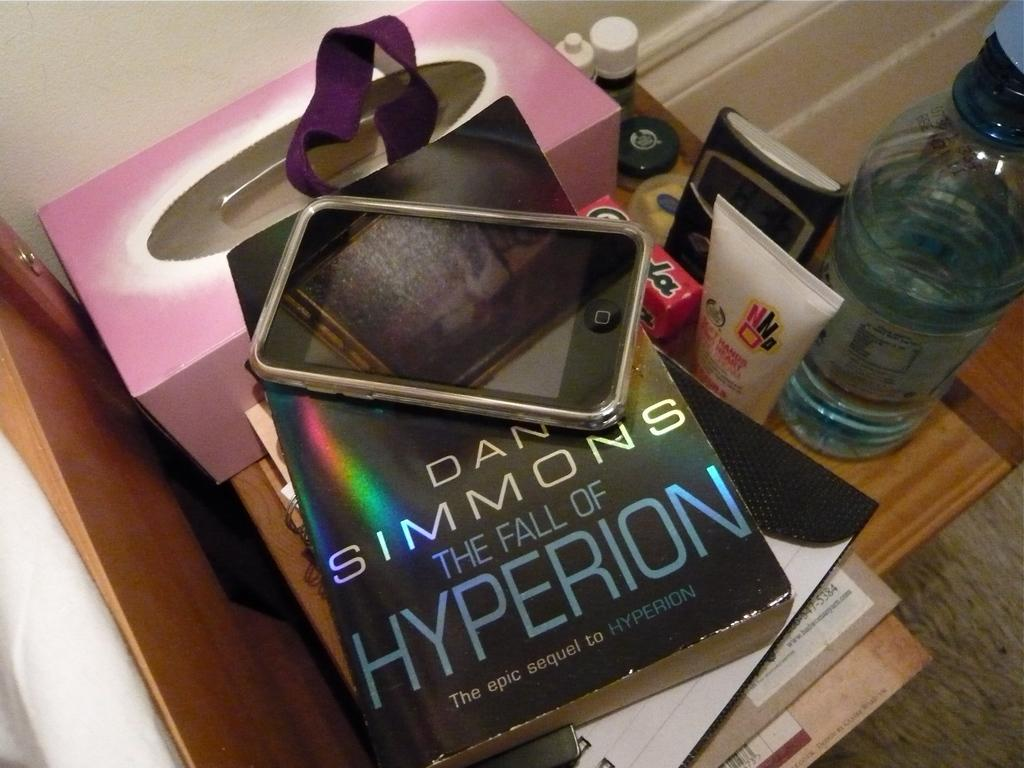<image>
Write a terse but informative summary of the picture. Book called The Fall of Hyperion by Dan Simmons under a phone. 